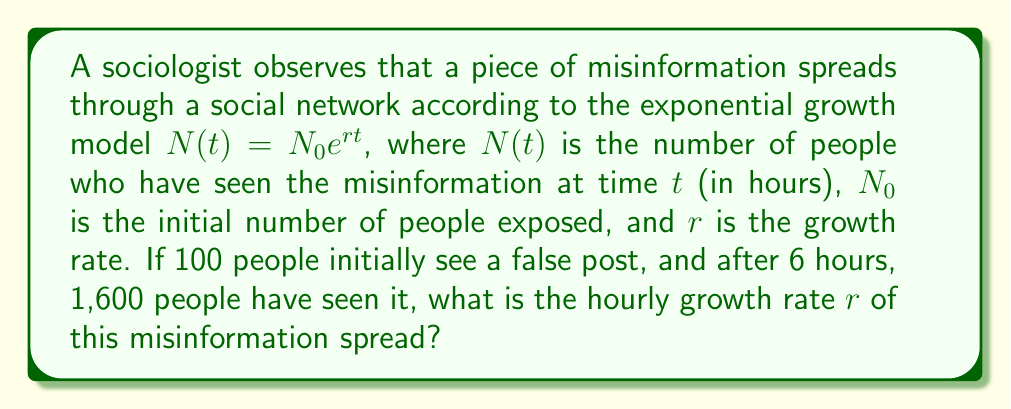Show me your answer to this math problem. Let's approach this step-by-step:

1) We are given the exponential growth model: $N(t) = N_0 e^{rt}$

2) We know the following:
   - $N_0 = 100$ (initial number of people)
   - $N(6) = 1600$ (after 6 hours, 1600 people have seen it)
   - $t = 6$ (time in hours)

3) Let's substitute these values into our equation:

   $1600 = 100 e^{r(6)}$

4) Divide both sides by 100:

   $16 = e^{6r}$

5) Take the natural logarithm of both sides:

   $\ln(16) = 6r$

6) Solve for $r$:

   $r = \frac{\ln(16)}{6}$

7) Calculate:
   
   $r = \frac{\ln(16)}{6} = \frac{2.77259}{6} \approx 0.46210$

Therefore, the hourly growth rate is approximately 0.46210 or 46.210% per hour.
Answer: $r \approx 0.46210$ per hour 